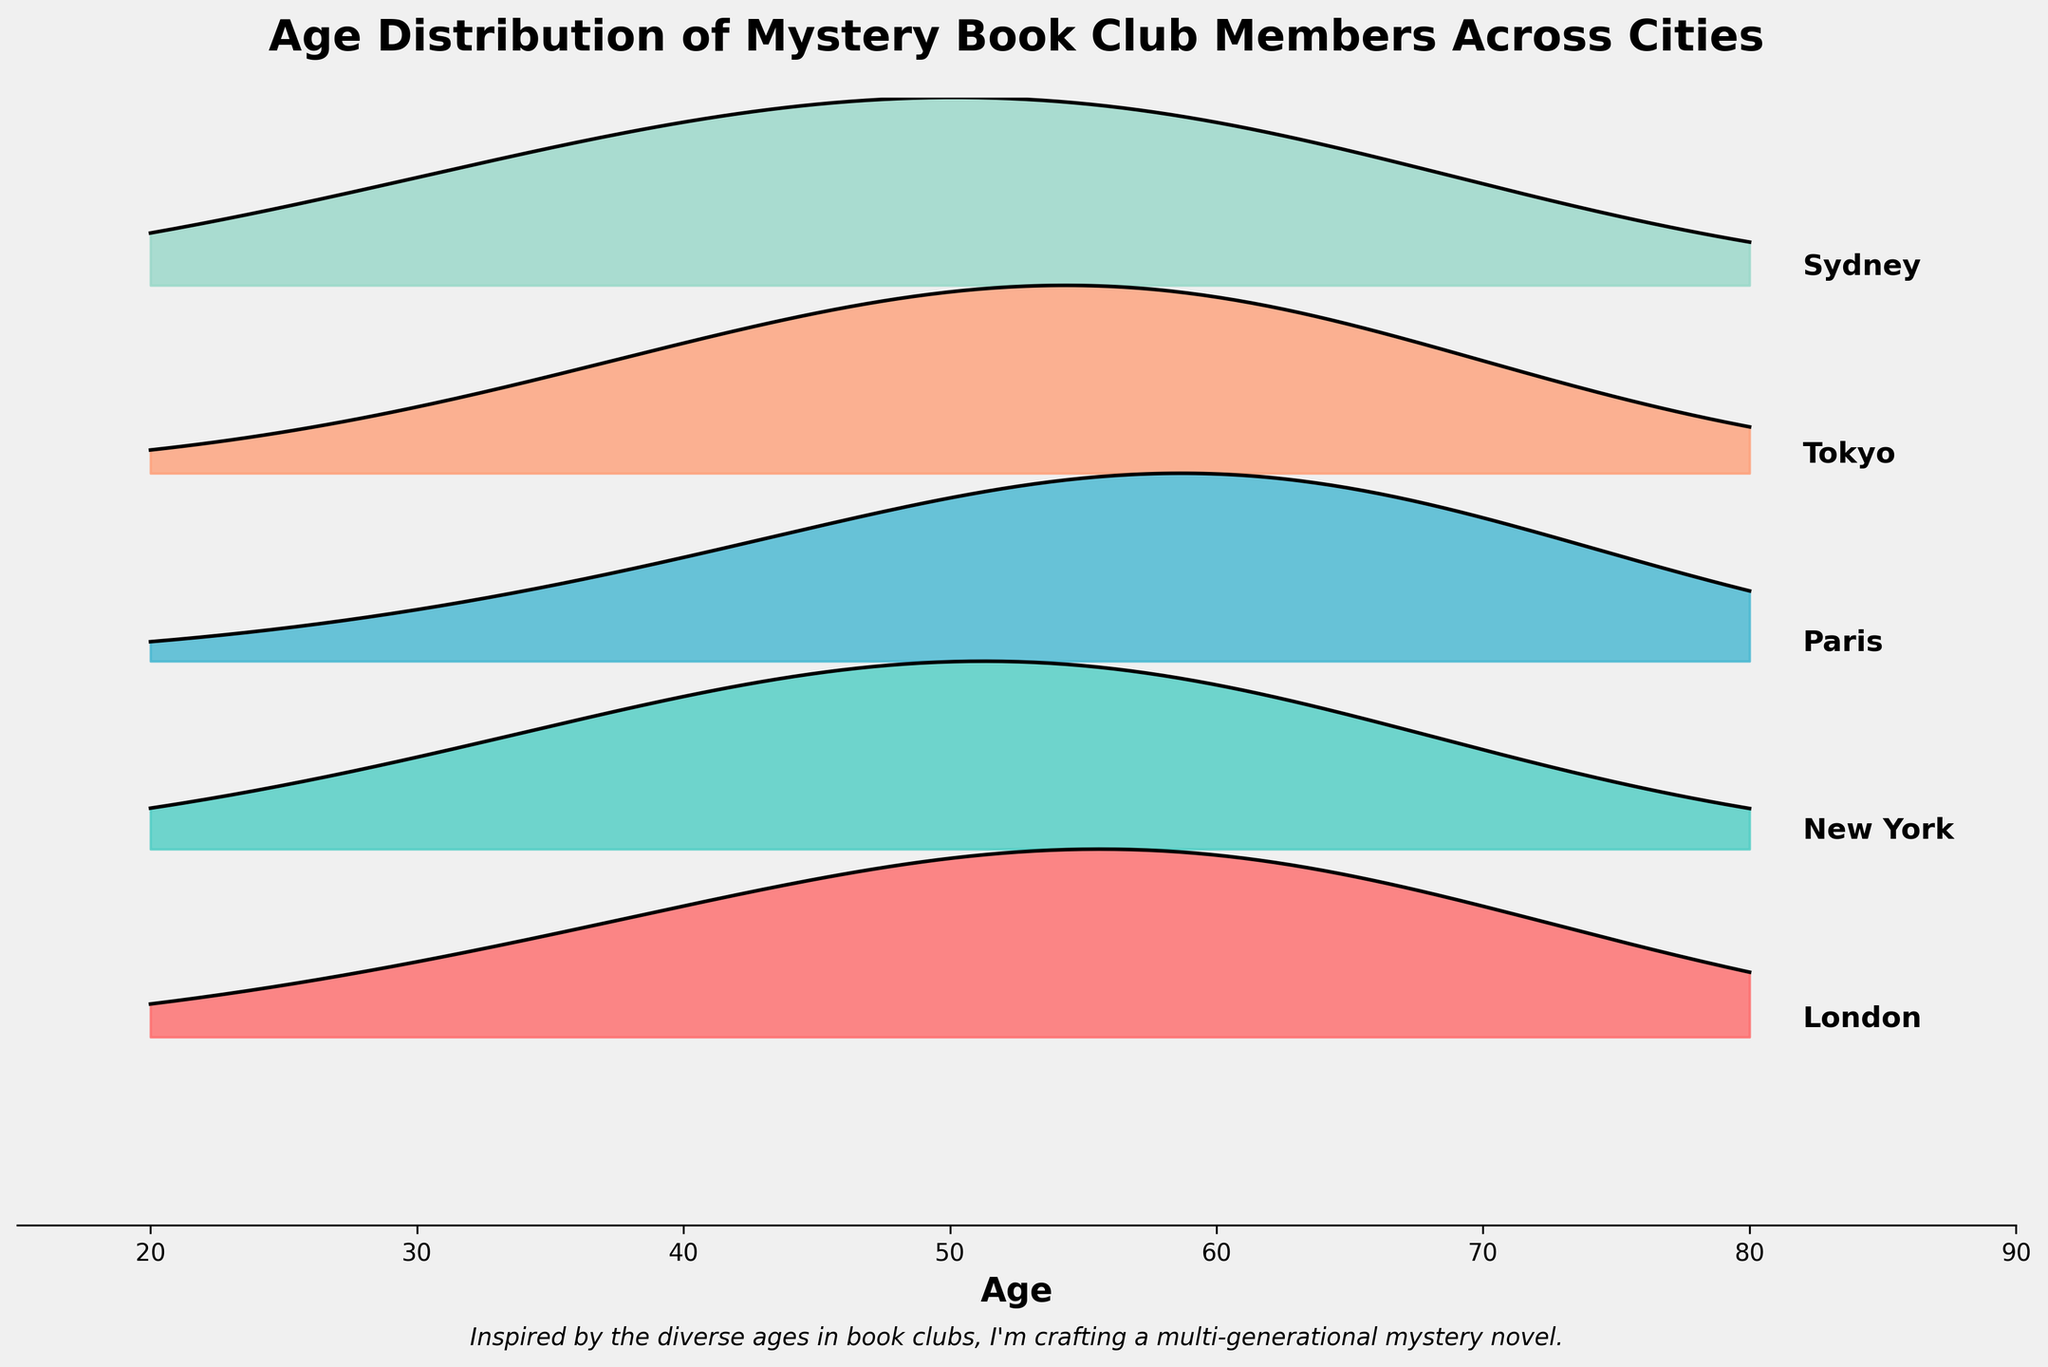What is the title of the plot? The title is located at the top of the plot. It reads 'Age Distribution of Mystery Book Club Members Across Cities.'
Answer: Age Distribution of Mystery Book Club Members Across Cities Which city has the highest density of members in their 60s? Look at the density values on the plot for each city at the age of 60. Paris has the highest density value at this age, which is 0.35.
Answer: Paris What is the age range displayed on the x-axis? The x-axis starts at 15 and ends at 90, indicating the range of ages considered for the book club members.
Answer: 15 to 90 Which city has the most uniform age distribution? Uniform distribution means that the density values are more evenly spread across different ages. London shows a relatively uniform distribution with no sharp peaks or dips.
Answer: London How does the density of book club members aged 50 compare between Tokyo and Sydney? Check the density values for the age of 50 for both cities. Tokyo has a density of 0.28 and Sydney has 0.26. Therefore, Tokyo has a slightly higher density.
Answer: Tokyo What's the most common age group of book club members in New York? Look for the age group with the highest density value in New York. The highest density value is 0.30 at the age of 50.
Answer: 50 Which city has the least number of young members aged 20? Compare the density values for the age of 20 across all cities. Paris and Tokyo both have a density value of 0.01, the lowest among the cities.
Answer: Paris and Tokyo What is the total number of cities plotted? Count the unique city names mentioned on the plot. They are London, New York, Paris, Tokyo, and Sydney, making a total of 5 cities.
Answer: 5 Is the distribution of age in Paris skewed towards older or younger members? Look at the density values across different ages in Paris. The peak density is at age 60 (0.35), indicating a skew towards older members.
Answer: Older members Which city has the highest peak density, and at which age does it occur? Identify the highest density value among all the cities. Paris has the highest peak density value of 0.35, occurring at age 60.
Answer: Paris at age 60 